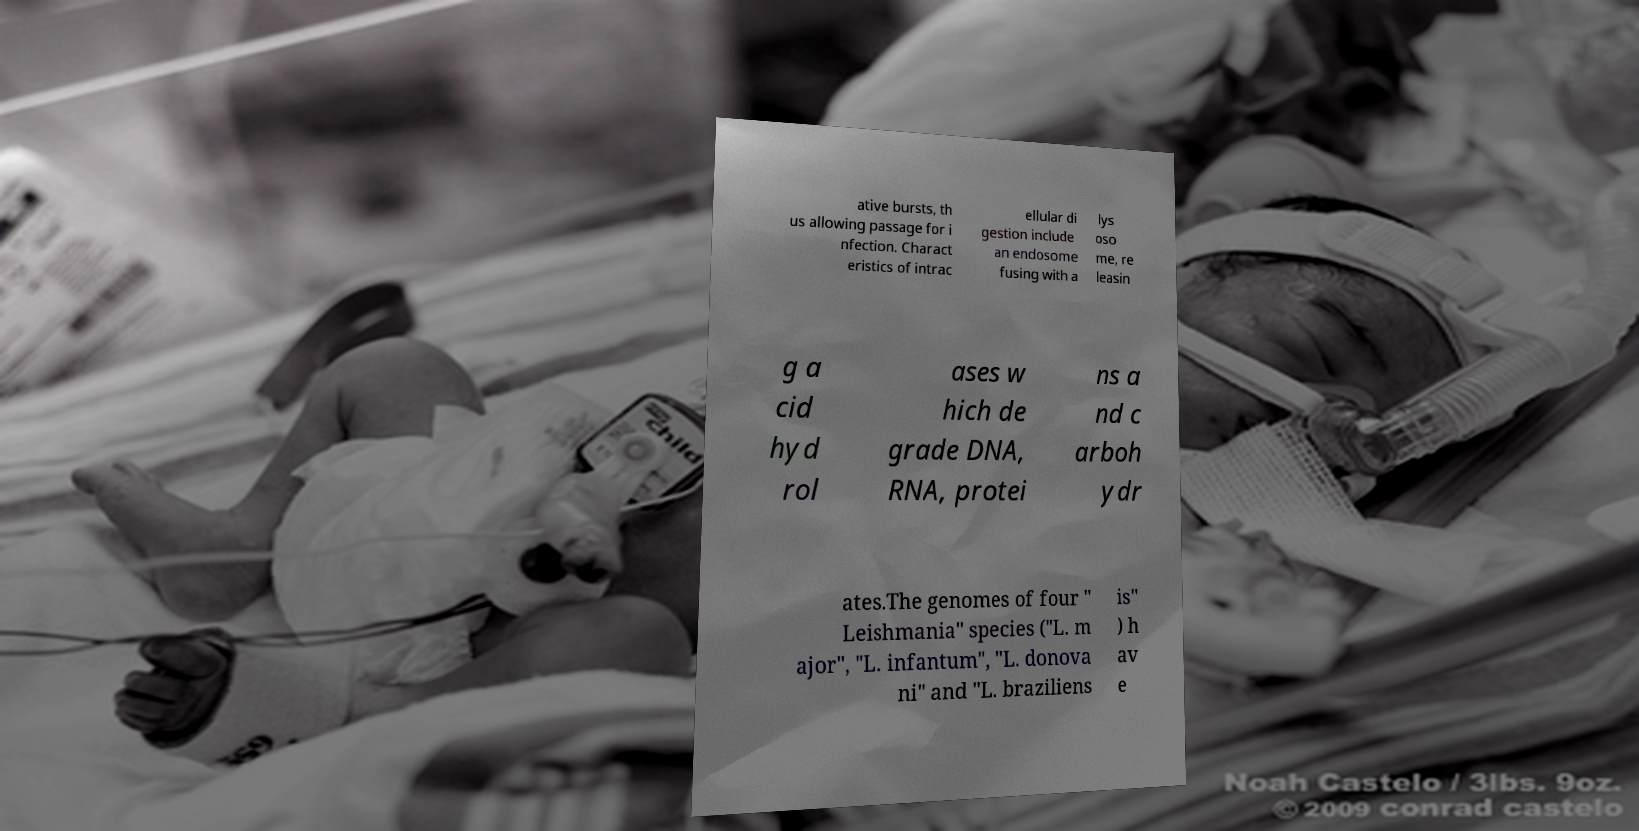Can you accurately transcribe the text from the provided image for me? ative bursts, th us allowing passage for i nfection. Charact eristics of intrac ellular di gestion include an endosome fusing with a lys oso me, re leasin g a cid hyd rol ases w hich de grade DNA, RNA, protei ns a nd c arboh ydr ates.The genomes of four " Leishmania" species ("L. m ajor", "L. infantum", "L. donova ni" and "L. braziliens is" ) h av e 